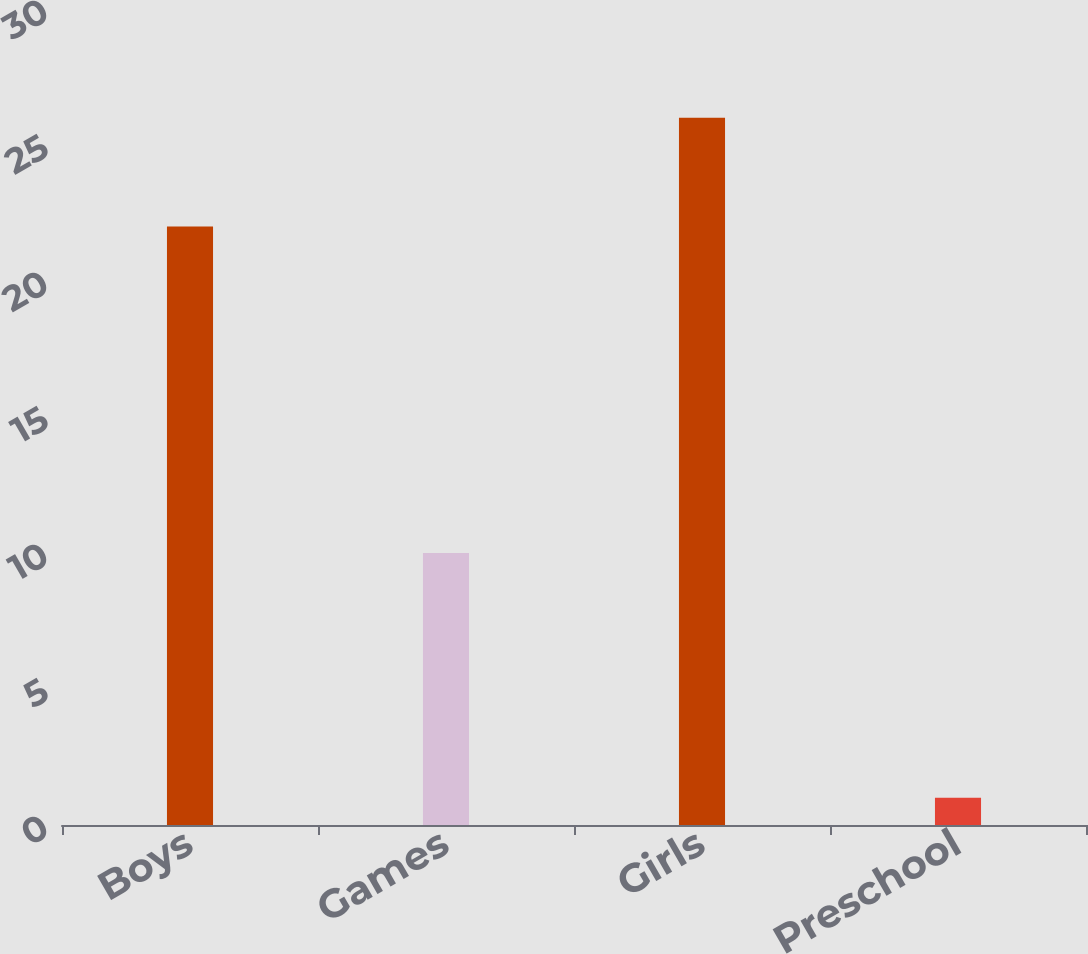<chart> <loc_0><loc_0><loc_500><loc_500><bar_chart><fcel>Boys<fcel>Games<fcel>Girls<fcel>Preschool<nl><fcel>22<fcel>10<fcel>26<fcel>1<nl></chart> 